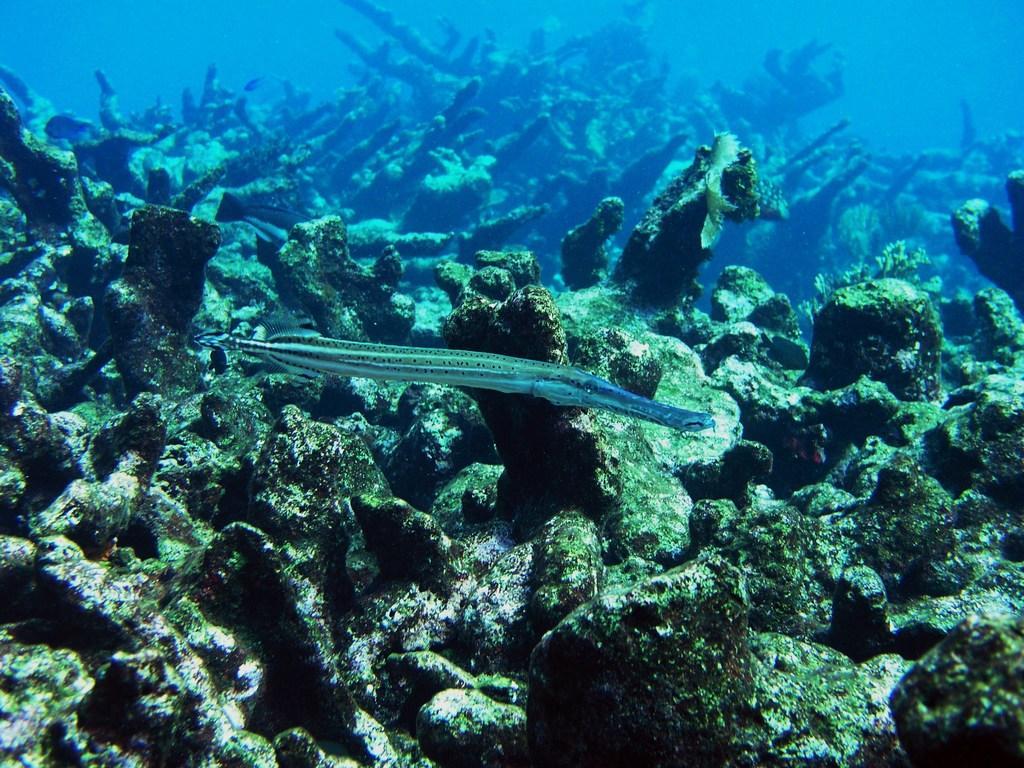Describe this image in one or two sentences. In this image we can see a fish, stones and some plants in the water. 